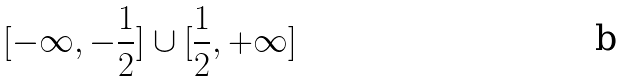Convert formula to latex. <formula><loc_0><loc_0><loc_500><loc_500>[ - \infty , - \frac { 1 } { 2 } ] \cup [ \frac { 1 } { 2 } , + \infty ]</formula> 